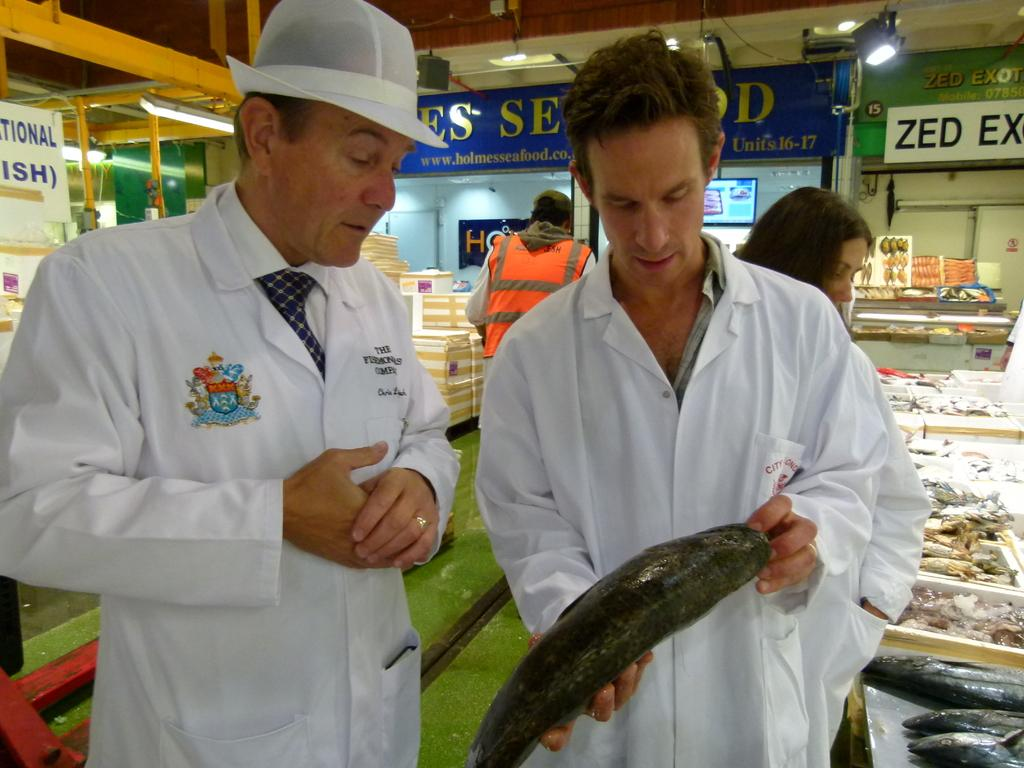<image>
Provide a brief description of the given image. A man holding a fish, and a sign that says zed ex on it 